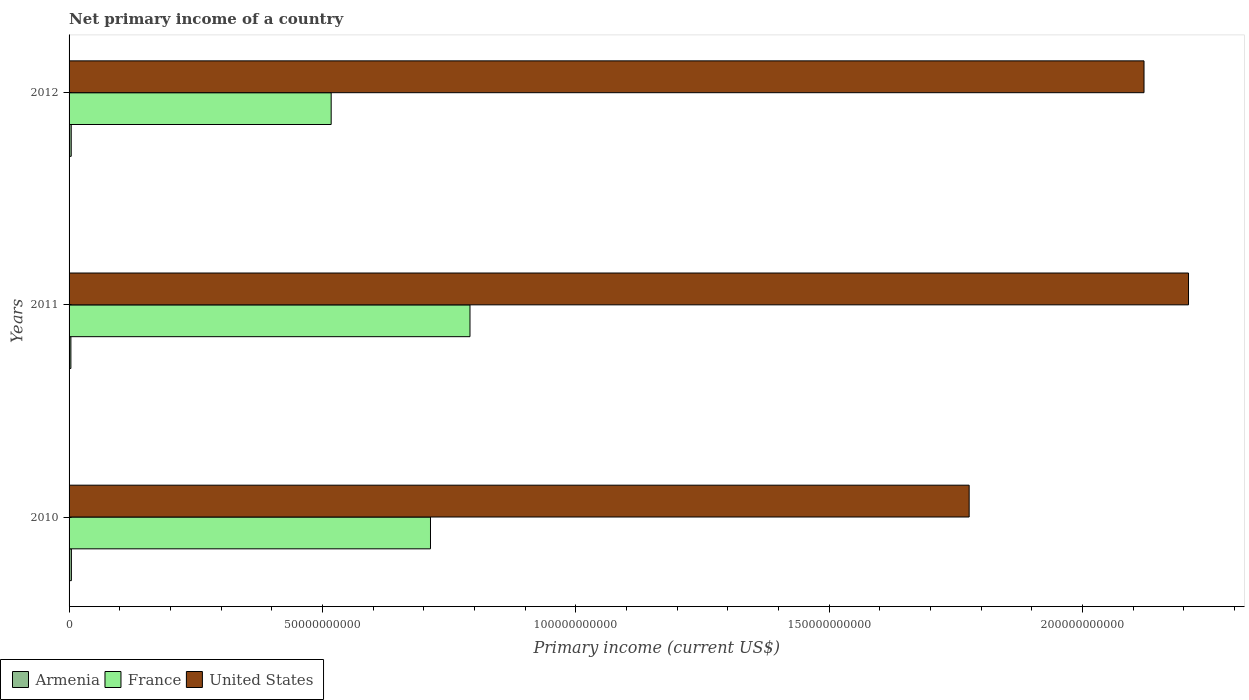How many different coloured bars are there?
Keep it short and to the point. 3. How many groups of bars are there?
Keep it short and to the point. 3. How many bars are there on the 3rd tick from the bottom?
Provide a short and direct response. 3. What is the label of the 1st group of bars from the top?
Keep it short and to the point. 2012. What is the primary income in United States in 2010?
Your response must be concise. 1.78e+11. Across all years, what is the maximum primary income in United States?
Offer a terse response. 2.21e+11. Across all years, what is the minimum primary income in United States?
Make the answer very short. 1.78e+11. In which year was the primary income in France maximum?
Make the answer very short. 2011. In which year was the primary income in France minimum?
Ensure brevity in your answer.  2012. What is the total primary income in France in the graph?
Your answer should be compact. 2.02e+11. What is the difference between the primary income in United States in 2011 and that in 2012?
Offer a terse response. 8.78e+09. What is the difference between the primary income in United States in 2010 and the primary income in Armenia in 2012?
Your response must be concise. 1.77e+11. What is the average primary income in United States per year?
Ensure brevity in your answer.  2.04e+11. In the year 2011, what is the difference between the primary income in Armenia and primary income in United States?
Ensure brevity in your answer.  -2.21e+11. What is the ratio of the primary income in Armenia in 2010 to that in 2012?
Keep it short and to the point. 1.08. Is the difference between the primary income in Armenia in 2010 and 2011 greater than the difference between the primary income in United States in 2010 and 2011?
Provide a short and direct response. Yes. What is the difference between the highest and the second highest primary income in United States?
Ensure brevity in your answer.  8.78e+09. What is the difference between the highest and the lowest primary income in France?
Keep it short and to the point. 2.74e+1. Is the sum of the primary income in Armenia in 2011 and 2012 greater than the maximum primary income in United States across all years?
Offer a very short reply. No. What does the 3rd bar from the top in 2012 represents?
Offer a very short reply. Armenia. What does the 2nd bar from the bottom in 2011 represents?
Make the answer very short. France. Is it the case that in every year, the sum of the primary income in France and primary income in Armenia is greater than the primary income in United States?
Offer a terse response. No. How many bars are there?
Offer a very short reply. 9. Are all the bars in the graph horizontal?
Your answer should be compact. Yes. How many years are there in the graph?
Your answer should be compact. 3. Does the graph contain grids?
Give a very brief answer. No. How many legend labels are there?
Your answer should be very brief. 3. What is the title of the graph?
Keep it short and to the point. Net primary income of a country. What is the label or title of the X-axis?
Provide a succinct answer. Primary income (current US$). What is the label or title of the Y-axis?
Keep it short and to the point. Years. What is the Primary income (current US$) of Armenia in 2010?
Offer a terse response. 4.58e+08. What is the Primary income (current US$) in France in 2010?
Your answer should be compact. 7.13e+1. What is the Primary income (current US$) of United States in 2010?
Provide a short and direct response. 1.78e+11. What is the Primary income (current US$) of Armenia in 2011?
Offer a terse response. 3.60e+08. What is the Primary income (current US$) in France in 2011?
Provide a succinct answer. 7.91e+1. What is the Primary income (current US$) of United States in 2011?
Offer a terse response. 2.21e+11. What is the Primary income (current US$) in Armenia in 2012?
Ensure brevity in your answer.  4.23e+08. What is the Primary income (current US$) of France in 2012?
Provide a succinct answer. 5.17e+1. What is the Primary income (current US$) of United States in 2012?
Provide a succinct answer. 2.12e+11. Across all years, what is the maximum Primary income (current US$) of Armenia?
Your answer should be very brief. 4.58e+08. Across all years, what is the maximum Primary income (current US$) in France?
Keep it short and to the point. 7.91e+1. Across all years, what is the maximum Primary income (current US$) of United States?
Provide a short and direct response. 2.21e+11. Across all years, what is the minimum Primary income (current US$) of Armenia?
Your answer should be very brief. 3.60e+08. Across all years, what is the minimum Primary income (current US$) in France?
Give a very brief answer. 5.17e+1. Across all years, what is the minimum Primary income (current US$) of United States?
Provide a short and direct response. 1.78e+11. What is the total Primary income (current US$) of Armenia in the graph?
Offer a terse response. 1.24e+09. What is the total Primary income (current US$) in France in the graph?
Your response must be concise. 2.02e+11. What is the total Primary income (current US$) in United States in the graph?
Offer a terse response. 6.11e+11. What is the difference between the Primary income (current US$) in Armenia in 2010 and that in 2011?
Give a very brief answer. 9.82e+07. What is the difference between the Primary income (current US$) of France in 2010 and that in 2011?
Provide a short and direct response. -7.80e+09. What is the difference between the Primary income (current US$) of United States in 2010 and that in 2011?
Offer a very short reply. -4.33e+1. What is the difference between the Primary income (current US$) of Armenia in 2010 and that in 2012?
Ensure brevity in your answer.  3.52e+07. What is the difference between the Primary income (current US$) in France in 2010 and that in 2012?
Keep it short and to the point. 1.96e+1. What is the difference between the Primary income (current US$) in United States in 2010 and that in 2012?
Provide a short and direct response. -3.45e+1. What is the difference between the Primary income (current US$) of Armenia in 2011 and that in 2012?
Keep it short and to the point. -6.30e+07. What is the difference between the Primary income (current US$) of France in 2011 and that in 2012?
Provide a succinct answer. 2.74e+1. What is the difference between the Primary income (current US$) in United States in 2011 and that in 2012?
Offer a terse response. 8.78e+09. What is the difference between the Primary income (current US$) in Armenia in 2010 and the Primary income (current US$) in France in 2011?
Keep it short and to the point. -7.87e+1. What is the difference between the Primary income (current US$) in Armenia in 2010 and the Primary income (current US$) in United States in 2011?
Give a very brief answer. -2.21e+11. What is the difference between the Primary income (current US$) of France in 2010 and the Primary income (current US$) of United States in 2011?
Ensure brevity in your answer.  -1.50e+11. What is the difference between the Primary income (current US$) in Armenia in 2010 and the Primary income (current US$) in France in 2012?
Your response must be concise. -5.13e+1. What is the difference between the Primary income (current US$) in Armenia in 2010 and the Primary income (current US$) in United States in 2012?
Your response must be concise. -2.12e+11. What is the difference between the Primary income (current US$) in France in 2010 and the Primary income (current US$) in United States in 2012?
Offer a terse response. -1.41e+11. What is the difference between the Primary income (current US$) in Armenia in 2011 and the Primary income (current US$) in France in 2012?
Keep it short and to the point. -5.14e+1. What is the difference between the Primary income (current US$) in Armenia in 2011 and the Primary income (current US$) in United States in 2012?
Provide a short and direct response. -2.12e+11. What is the difference between the Primary income (current US$) of France in 2011 and the Primary income (current US$) of United States in 2012?
Provide a succinct answer. -1.33e+11. What is the average Primary income (current US$) in Armenia per year?
Give a very brief answer. 4.14e+08. What is the average Primary income (current US$) in France per year?
Offer a terse response. 6.74e+1. What is the average Primary income (current US$) of United States per year?
Provide a succinct answer. 2.04e+11. In the year 2010, what is the difference between the Primary income (current US$) in Armenia and Primary income (current US$) in France?
Give a very brief answer. -7.09e+1. In the year 2010, what is the difference between the Primary income (current US$) of Armenia and Primary income (current US$) of United States?
Give a very brief answer. -1.77e+11. In the year 2010, what is the difference between the Primary income (current US$) of France and Primary income (current US$) of United States?
Your answer should be compact. -1.06e+11. In the year 2011, what is the difference between the Primary income (current US$) in Armenia and Primary income (current US$) in France?
Ensure brevity in your answer.  -7.88e+1. In the year 2011, what is the difference between the Primary income (current US$) of Armenia and Primary income (current US$) of United States?
Give a very brief answer. -2.21e+11. In the year 2011, what is the difference between the Primary income (current US$) in France and Primary income (current US$) in United States?
Provide a short and direct response. -1.42e+11. In the year 2012, what is the difference between the Primary income (current US$) of Armenia and Primary income (current US$) of France?
Provide a succinct answer. -5.13e+1. In the year 2012, what is the difference between the Primary income (current US$) in Armenia and Primary income (current US$) in United States?
Offer a very short reply. -2.12e+11. In the year 2012, what is the difference between the Primary income (current US$) of France and Primary income (current US$) of United States?
Offer a very short reply. -1.60e+11. What is the ratio of the Primary income (current US$) in Armenia in 2010 to that in 2011?
Ensure brevity in your answer.  1.27. What is the ratio of the Primary income (current US$) in France in 2010 to that in 2011?
Offer a terse response. 0.9. What is the ratio of the Primary income (current US$) of United States in 2010 to that in 2011?
Offer a terse response. 0.8. What is the ratio of the Primary income (current US$) in Armenia in 2010 to that in 2012?
Provide a short and direct response. 1.08. What is the ratio of the Primary income (current US$) of France in 2010 to that in 2012?
Offer a very short reply. 1.38. What is the ratio of the Primary income (current US$) in United States in 2010 to that in 2012?
Make the answer very short. 0.84. What is the ratio of the Primary income (current US$) in Armenia in 2011 to that in 2012?
Ensure brevity in your answer.  0.85. What is the ratio of the Primary income (current US$) of France in 2011 to that in 2012?
Keep it short and to the point. 1.53. What is the ratio of the Primary income (current US$) of United States in 2011 to that in 2012?
Your answer should be compact. 1.04. What is the difference between the highest and the second highest Primary income (current US$) of Armenia?
Your answer should be very brief. 3.52e+07. What is the difference between the highest and the second highest Primary income (current US$) in France?
Ensure brevity in your answer.  7.80e+09. What is the difference between the highest and the second highest Primary income (current US$) in United States?
Provide a short and direct response. 8.78e+09. What is the difference between the highest and the lowest Primary income (current US$) in Armenia?
Ensure brevity in your answer.  9.82e+07. What is the difference between the highest and the lowest Primary income (current US$) of France?
Provide a short and direct response. 2.74e+1. What is the difference between the highest and the lowest Primary income (current US$) in United States?
Offer a terse response. 4.33e+1. 